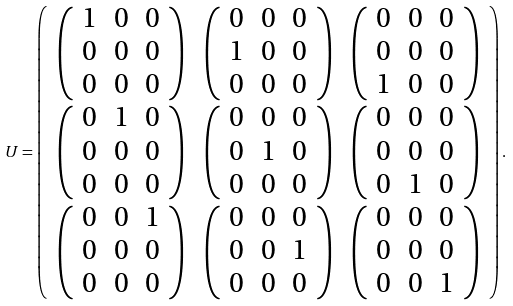<formula> <loc_0><loc_0><loc_500><loc_500>U = \left ( \begin{array} { c c c } \left ( \begin{array} { c c c } 1 & 0 & 0 \\ 0 & 0 & 0 \\ 0 & 0 & 0 \end{array} \right ) & \left ( \begin{array} { c c c } 0 & 0 & 0 \\ 1 & 0 & 0 \\ 0 & 0 & 0 \end{array} \right ) & \left ( \begin{array} { c c c } 0 & 0 & 0 \\ 0 & 0 & 0 \\ 1 & 0 & 0 \end{array} \right ) \\ \left ( \begin{array} { c c c } 0 & 1 & 0 \\ 0 & 0 & 0 \\ 0 & 0 & 0 \end{array} \right ) & \left ( \begin{array} { c c c } 0 & 0 & 0 \\ 0 & 1 & 0 \\ 0 & 0 & 0 \end{array} \right ) & \left ( \begin{array} { c c c } 0 & 0 & 0 \\ 0 & 0 & 0 \\ 0 & 1 & 0 \end{array} \right ) \\ \left ( \begin{array} { c c c } 0 & 0 & 1 \\ 0 & 0 & 0 \\ 0 & 0 & 0 \end{array} \right ) & \left ( \begin{array} { c c c } 0 & 0 & 0 \\ 0 & 0 & 1 \\ 0 & 0 & 0 \end{array} \right ) & \left ( \begin{array} { c c c } 0 & 0 & 0 \\ 0 & 0 & 0 \\ 0 & 0 & 1 \end{array} \right ) \end{array} \right ) .</formula> 